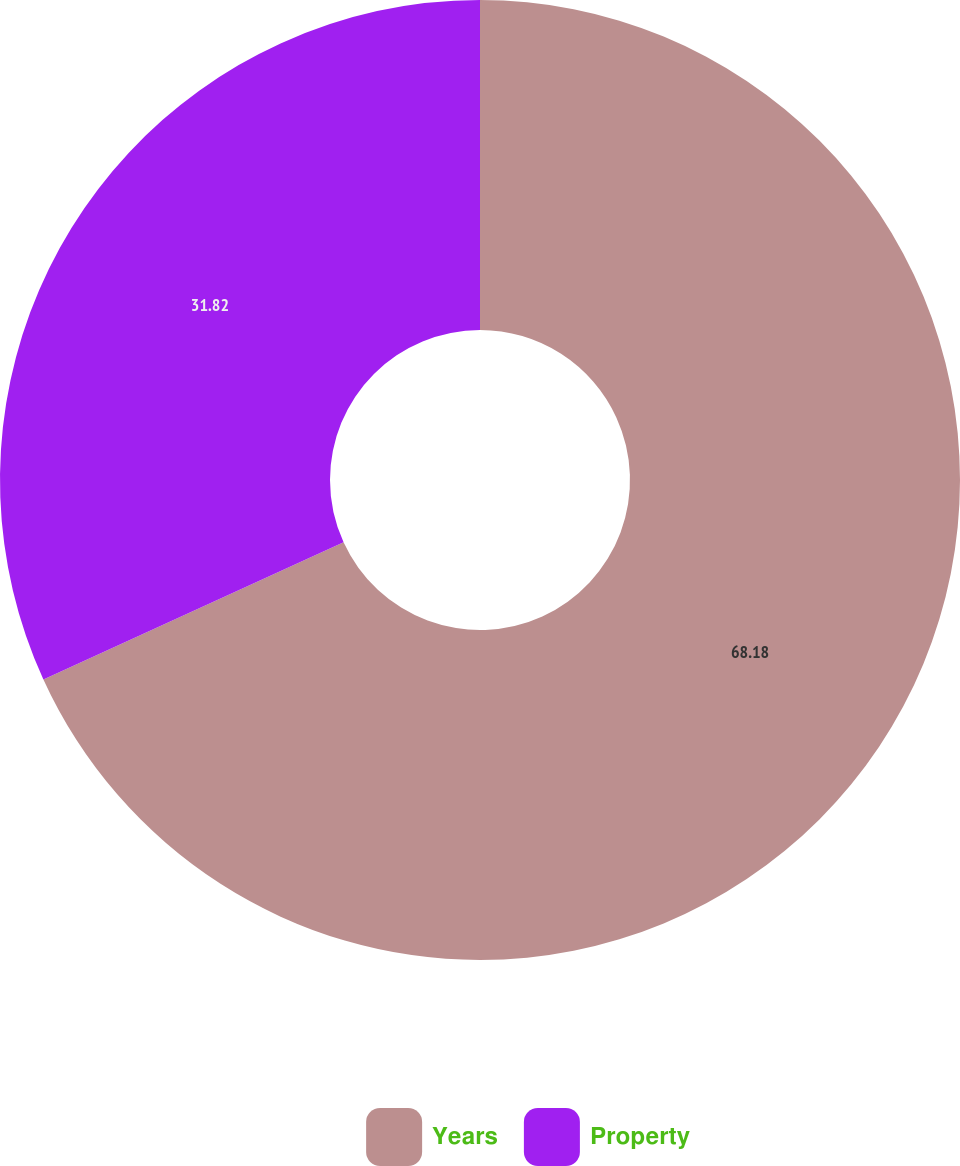<chart> <loc_0><loc_0><loc_500><loc_500><pie_chart><fcel>Years<fcel>Property<nl><fcel>68.18%<fcel>31.82%<nl></chart> 